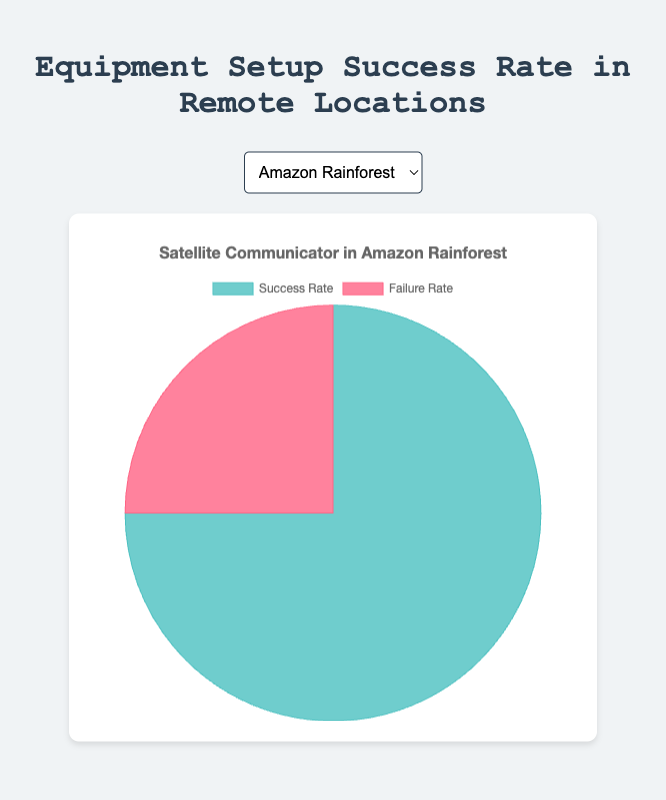What's the success rate of setting up a Satellite Communicator in the Amazon Rainforest? Refer to the slice labeled "Success Rate" for the Amazon Rainforest in the pie chart. The success rate value is indicated in the legend.
Answer: 75% What is the failure rate of the High-altitude UAV in the Himalayas? Refer to the slice labeled "Failure Rate" for the Himalayas in the pie chart. The failure rate value is indicated in the legend.
Answer: 45% Which location has the highest success rate for equipment setup? Compare the success rate values for all locations. The location with the largest "Success Rate" slice represents the highest success rate.
Answer: Outback Australia Which location has a higher success rate, the Sahara Desert or the Congo Basin? Refer to the success rate slices for both Sahara Desert and Congo Basin in the pie chart. Compare the values indicated in the legends.
Answer: Congo Basin What is the total failure rate for both the Portable Wind Turbine in Antarctica and the Sub-zero Temperature Logger in Siberia? Sum the failure rates for Antarctica (40%) and Siberia (35%) by adding their values. 40 + 35 = 75
Answer: 75% By how much does the success rate of the Water Purification Unit in Outback Australia exceed the success rate of the Portable Wind Turbine in Antarctica? Subtract the success rate of the Portable Wind Turbine in Antarctica (60%) from the success rate of the Water Purification Unit in Outback Australia (80%). 80 - 60 = 20
Answer: 20% Which equipment has the lowest success rate based on the pie charts? Compare the success rate slices across all pie charts. The smallest "Success Rate" slice represents the lowest success rate.
Answer: High-altitude UAV Is the failure rate higher for the Rain Gauge in the Congo Basin or the Sub-zero Temperature Logger in Siberia? Refer to the failure rate slices for both the Congo Basin and Siberia in the pie chart. Compare the values indicated in the legends.
Answer: Sub-zero Temperature Logger What is the average success rate for equipment setup in the Amazon Rainforest and Sahara Desert? Calculate the average of the success rates for the Amazon Rainforest (75%) and Sahara Desert (68%) by adding the two success rates and dividing by the number of locations: (75 + 68) / 2 = 71.5
Answer: 71.5 What is the difference in failure rate between the Satellite Communicator in the Amazon Rainforest and the High-altitude UAV in the Himalayas? Subtract the failure rate of the Satellite Communicator in the Amazon Rainforest (25%) from the failure rate of the High-altitude UAV in the Himalayas (45%). 45 - 25 = 20
Answer: 20% 